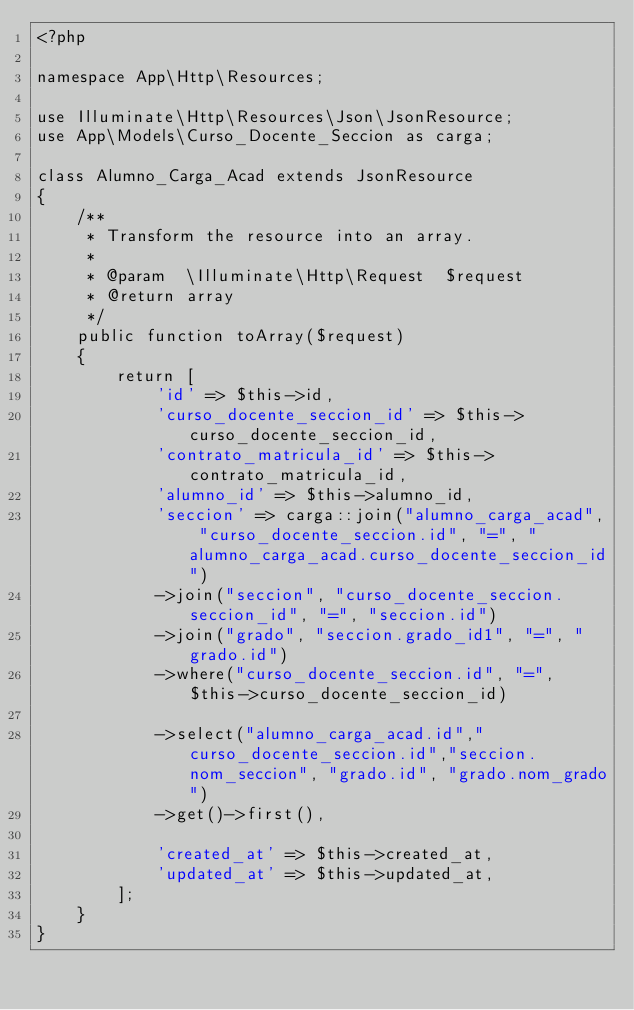<code> <loc_0><loc_0><loc_500><loc_500><_PHP_><?php
  
namespace App\Http\Resources;
   
use Illuminate\Http\Resources\Json\JsonResource;
use App\Models\Curso_Docente_Seccion as carga;
   
class Alumno_Carga_Acad extends JsonResource
{
    /**
     * Transform the resource into an array.
     *
     * @param  \Illuminate\Http\Request  $request
     * @return array
     */
    public function toArray($request)
    {
        return [
            'id' => $this->id,
            'curso_docente_seccion_id' => $this->curso_docente_seccion_id,
            'contrato_matricula_id' => $this->contrato_matricula_id,
            'alumno_id' => $this->alumno_id,
            'seccion' => carga::join("alumno_carga_acad", "curso_docente_seccion.id", "=", "alumno_carga_acad.curso_docente_seccion_id")
            ->join("seccion", "curso_docente_seccion.seccion_id", "=", "seccion.id")
            ->join("grado", "seccion.grado_id1", "=", "grado.id")
            ->where("curso_docente_seccion.id", "=", $this->curso_docente_seccion_id)
            
            ->select("alumno_carga_acad.id","curso_docente_seccion.id","seccion.nom_seccion", "grado.id", "grado.nom_grado")
            ->get()->first(),
            
            'created_at' => $this->created_at,
            'updated_at' => $this->updated_at,
        ];
    }
}</code> 